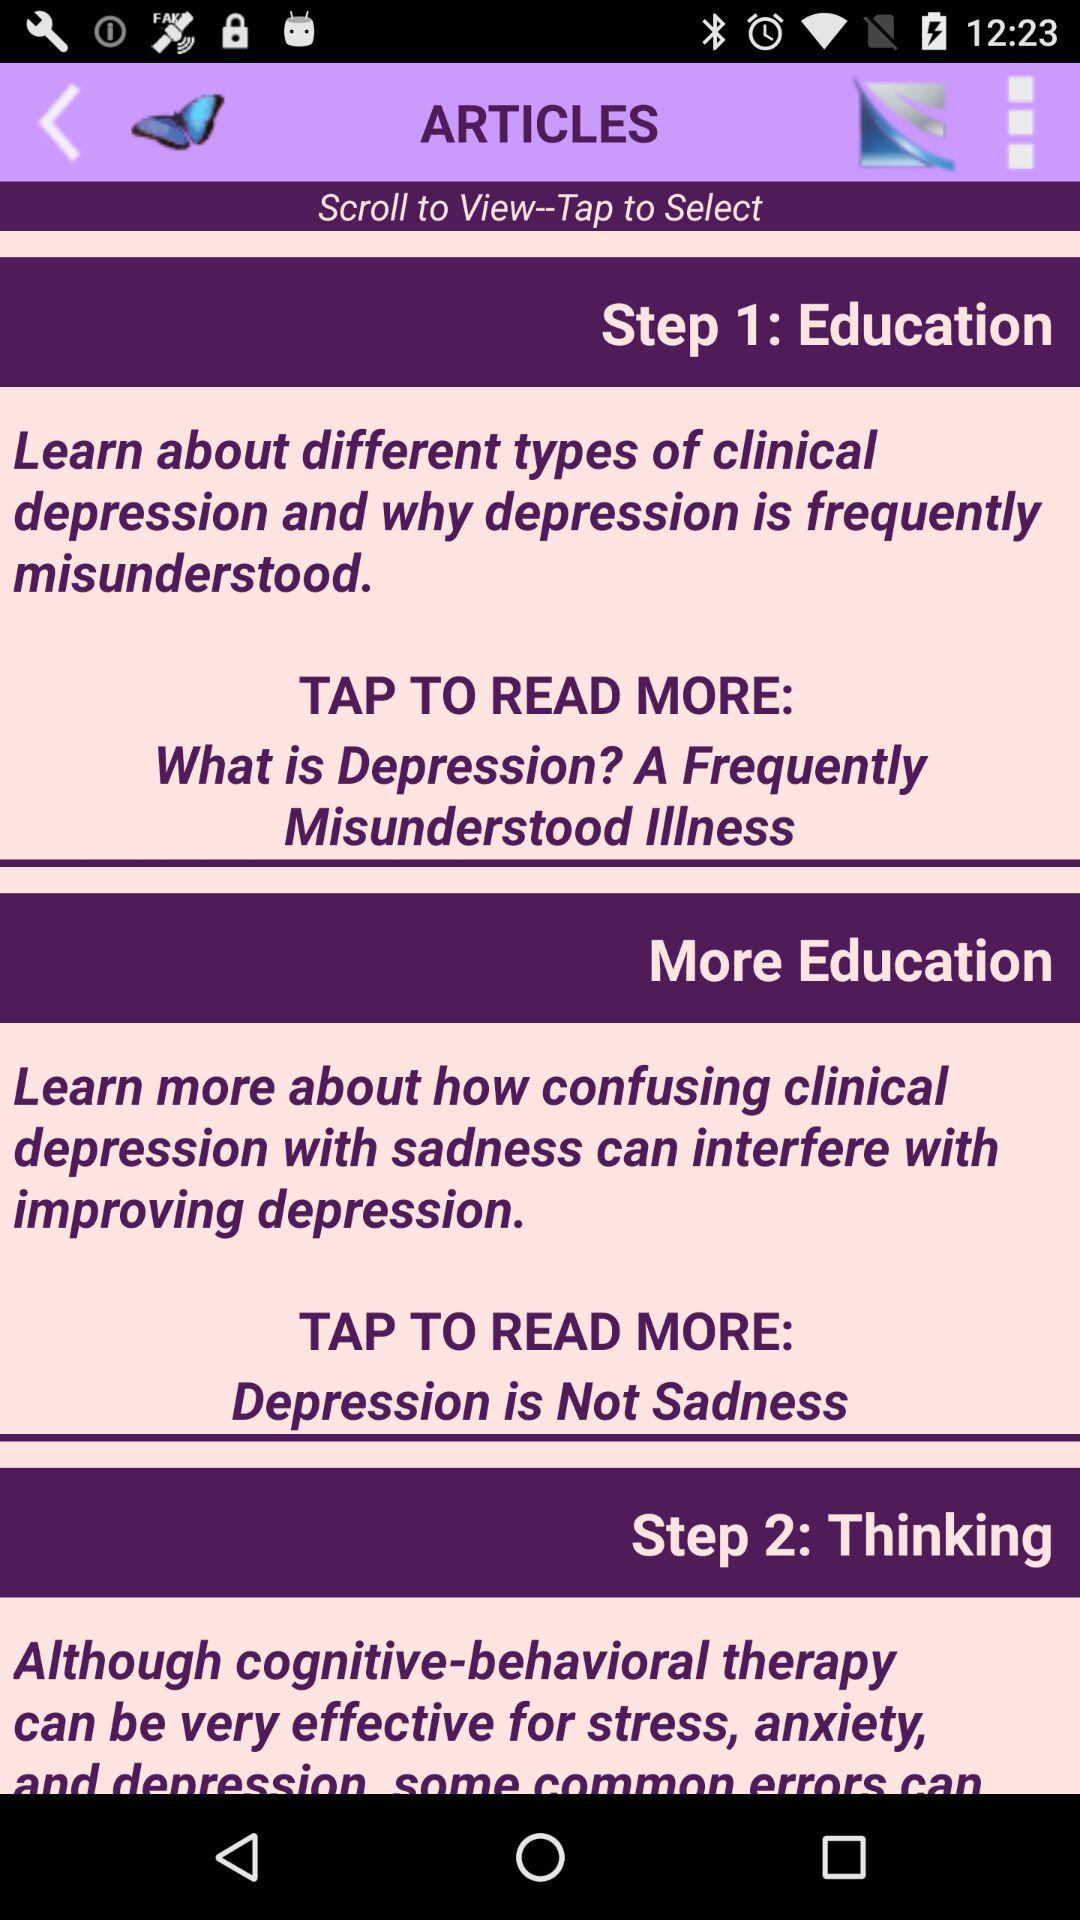Which article is present on step 1? - Which article is present in step 1? The article "What is Depression? A Frequently Misunderstood Illness" is present in step 1. 